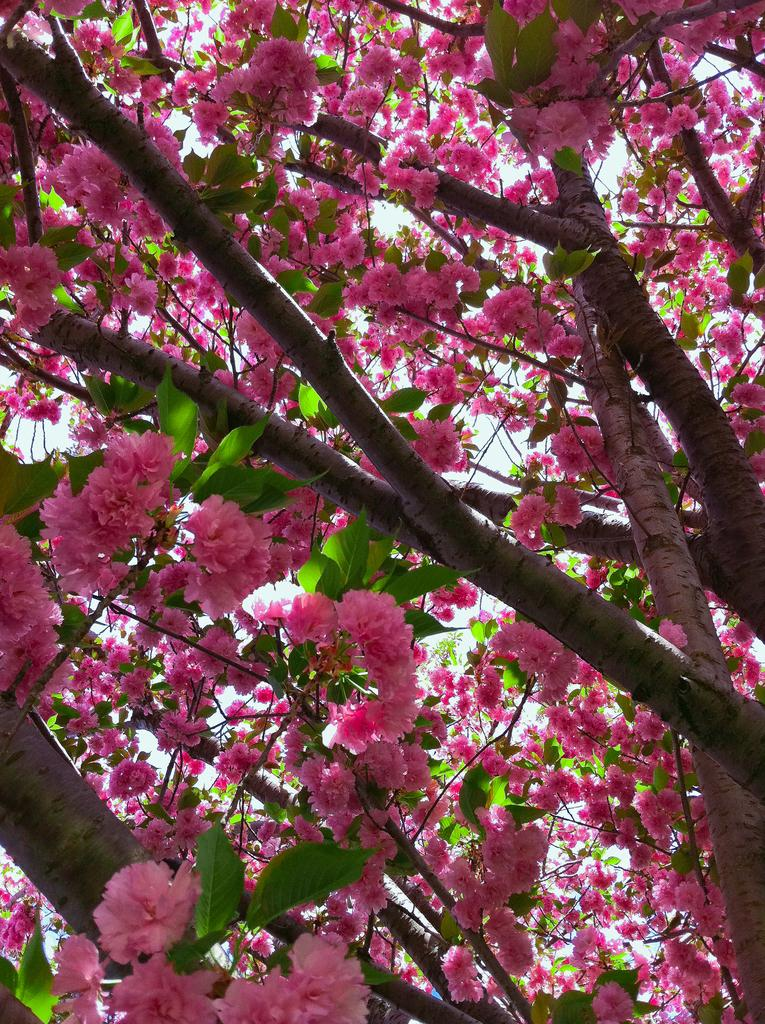What is present in the image? There is a tree in the image. What can be observed about the tree? The tree has flowers and leaves. What type of sleet can be seen falling from the tree in the image? There is no sleet present in the image; the tree has flowers and leaves. What is the reaction of the tree to the presence of cars in the image? There are no cars present in the image, so it is not possible to determine the tree's reaction. 